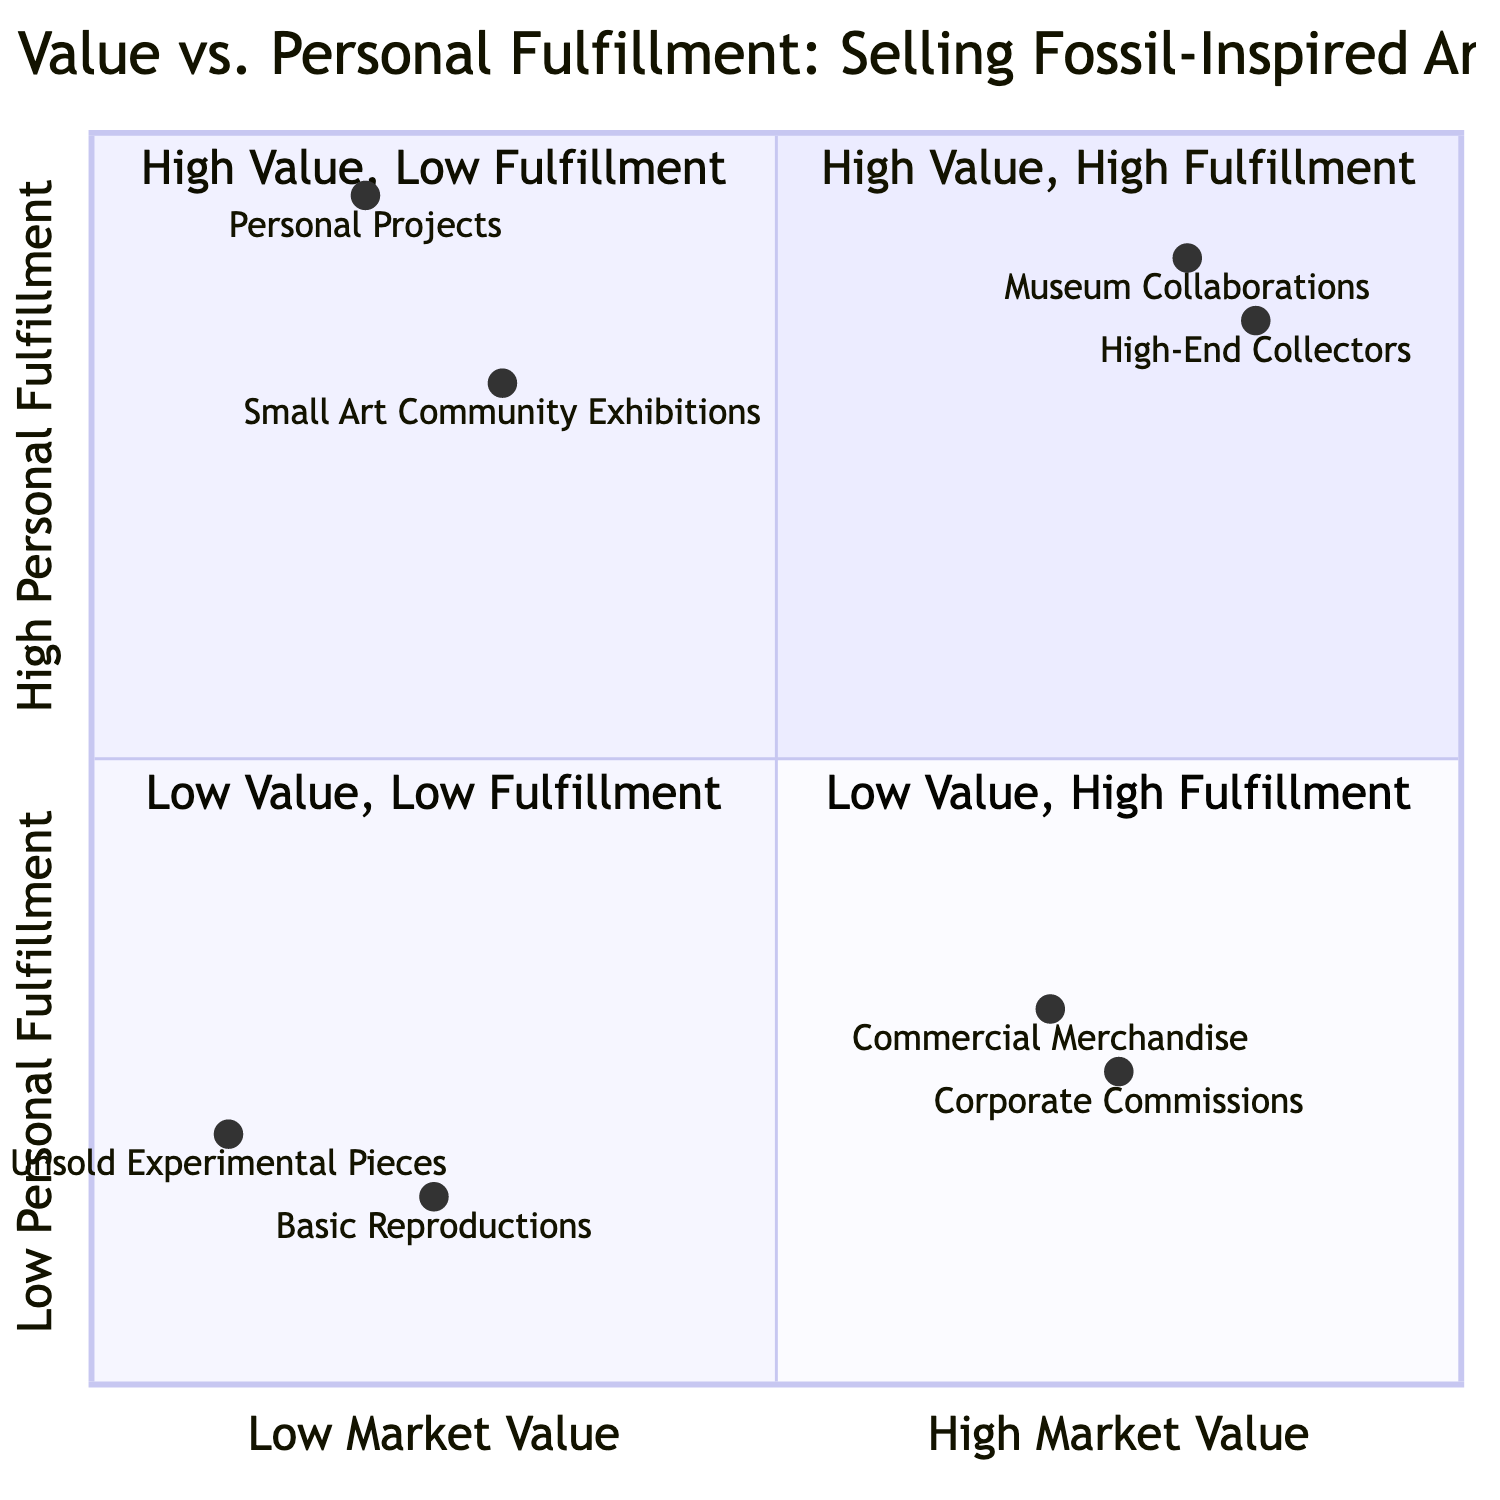What are the two examples in the High Market Value, High Personal Fulfillment quadrant? In the High Market Value, High Personal Fulfillment quadrant, there are two examples listed: Museum Collaborations and High-End Collectors.
Answer: Museum Collaborations, High-End Collectors Which example has the lowest personal fulfillment score? By looking at the personal fulfillment scores for each example, the Basic Reproductions has the lowest score at 0.15.
Answer: Basic Reproductions How many examples are in the Low Market Value, High Personal Fulfillment quadrant? The Low Market Value, High Personal Fulfillment quadrant contains two examples: Personal Projects and Small Art Community Exhibitions. Therefore, there are 2 examples.
Answer: 2 What is the personal fulfillment score of Corporate Commissions? The Corporate Commissions example has a personal fulfillment score of 0.25 according to the quadrant chart's information.
Answer: 0.25 Which quadrant contains the most satisfying art projects based on personal fulfillment? The quadrant titled Low Market Value, High Personal Fulfillment includes personal projects and local exhibitions, indicating it hosts the most satisfying projects based on personal fulfillment.
Answer: Low Market Value, High Personal Fulfillment What is the market value score of Museum Collaborations? The market value score for Museum Collaborations is given as 0.8 in the quadrant chart.
Answer: 0.8 